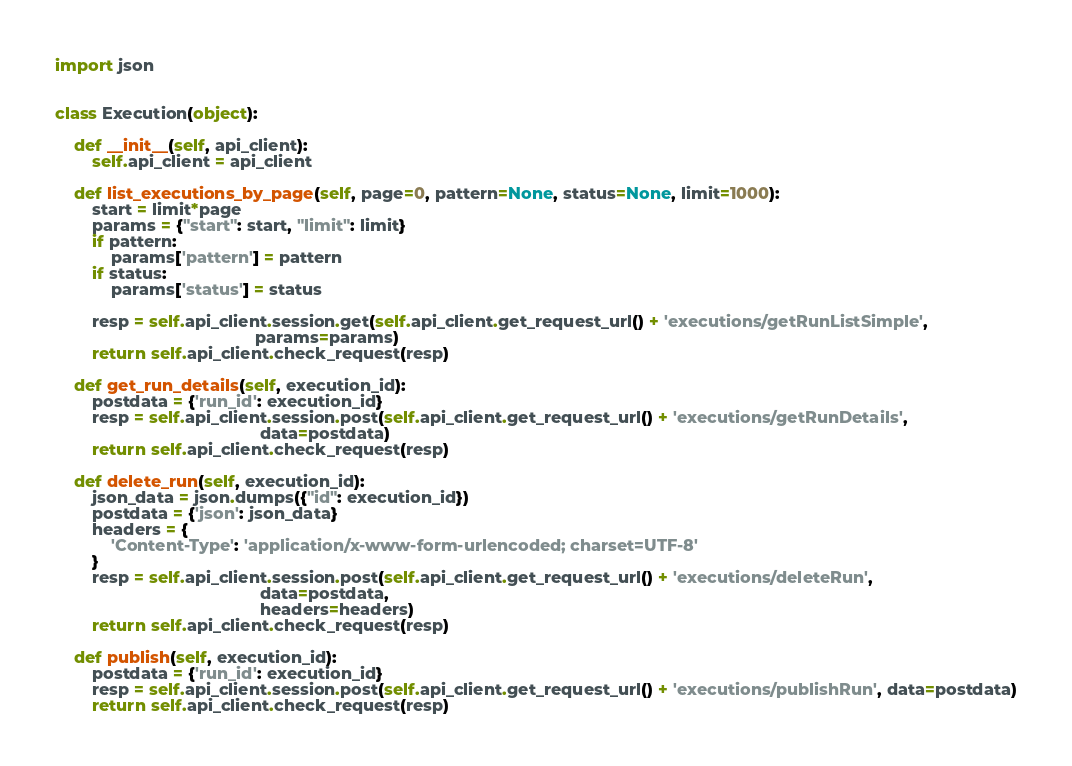Convert code to text. <code><loc_0><loc_0><loc_500><loc_500><_Python_>import json


class Execution(object):

    def __init__(self, api_client):
        self.api_client = api_client

    def list_executions_by_page(self, page=0, pattern=None, status=None, limit=1000):
        start = limit*page
        params = {"start": start, "limit": limit}
        if pattern:
            params['pattern'] = pattern
        if status:
            params['status'] = status

        resp = self.api_client.session.get(self.api_client.get_request_url() + 'executions/getRunListSimple',
                                           params=params)
        return self.api_client.check_request(resp)

    def get_run_details(self, execution_id):
        postdata = {'run_id': execution_id}
        resp = self.api_client.session.post(self.api_client.get_request_url() + 'executions/getRunDetails',
                                            data=postdata)
        return self.api_client.check_request(resp)

    def delete_run(self, execution_id):
        json_data = json.dumps({"id": execution_id})
        postdata = {'json': json_data}
        headers = {
            'Content-Type': 'application/x-www-form-urlencoded; charset=UTF-8'
        }
        resp = self.api_client.session.post(self.api_client.get_request_url() + 'executions/deleteRun',
                                            data=postdata,
                                            headers=headers)
        return self.api_client.check_request(resp)

    def publish(self, execution_id):
        postdata = {'run_id': execution_id}
        resp = self.api_client.session.post(self.api_client.get_request_url() + 'executions/publishRun', data=postdata)
        return self.api_client.check_request(resp)
</code> 